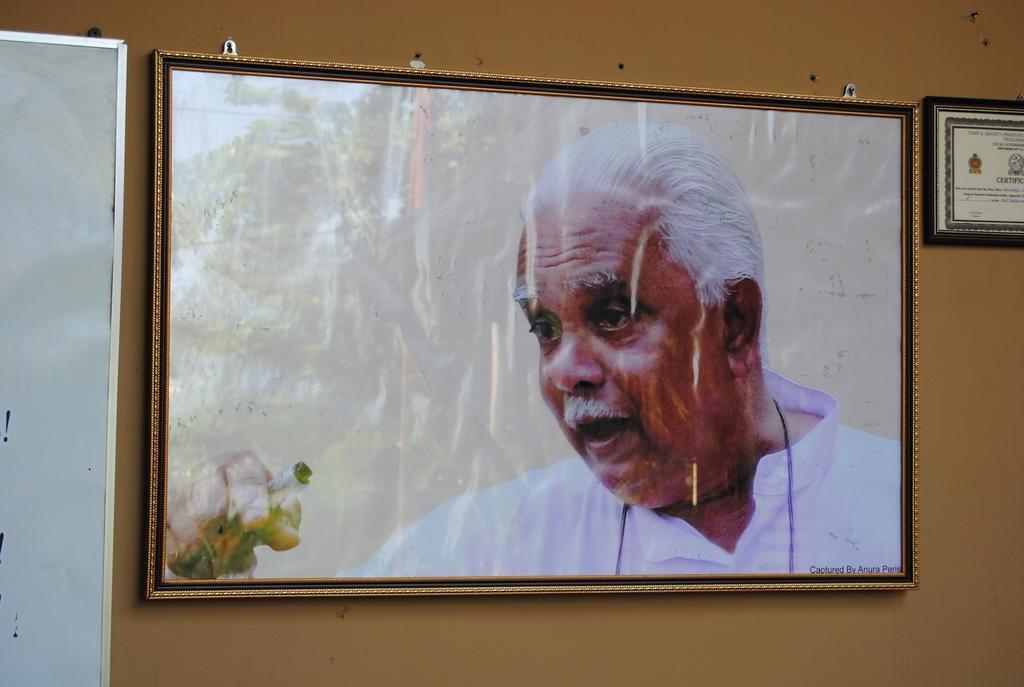Describe this image in one or two sentences. We can see frames and board on a wall on this frame we can see a man and tree. 